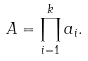Convert formula to latex. <formula><loc_0><loc_0><loc_500><loc_500>A = \prod _ { i = 1 } ^ { k } a _ { i } .</formula> 